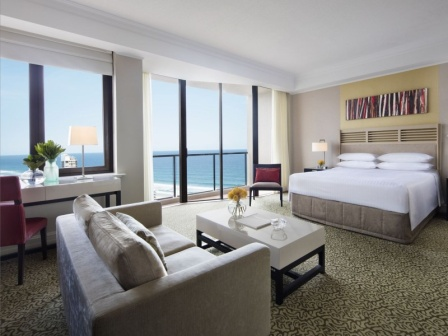What makes this hotel room an attractive place to stay? This hotel room is particularly attractive due to its spacious design and the stunning ocean view from the large window, which creates a serene and calming atmosphere. The modern and tasteful decor, including the plush gray sofa, stylish red armchair, and elegant black and white carpet, add to the appeal. The comfortable bed with crisp white linens and the vibrant abstract painting provide a perfect blend of relaxation and aesthetic pleasure. The balcony invites guests to enjoy the ocean breeze, making it an ideal spot for unwinding. 